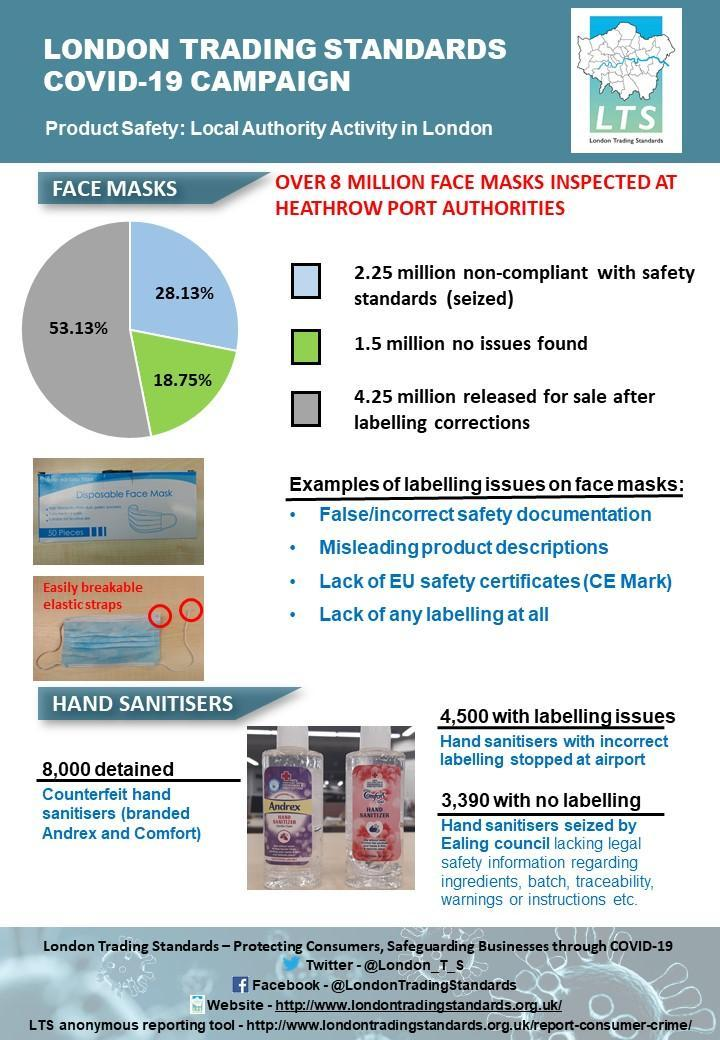What is stated second as example of face mask labelling issue?
Answer the question with a short phrase. Misleading product descriptions What was the percentage of face masks without any issues? 18.75 Who seized hand sanitisers lacking warnings or instructions? Ealing council Which brand names were used on fake sanitisers? Andrex and Comfort How many hand sanitisers did not have safety information, warnings or instructions? 3,390 What was wrong with 28.13% of the face masks? non-compliant with safety standards What was the percentage of face masks released for sale after corrections? 53.13 